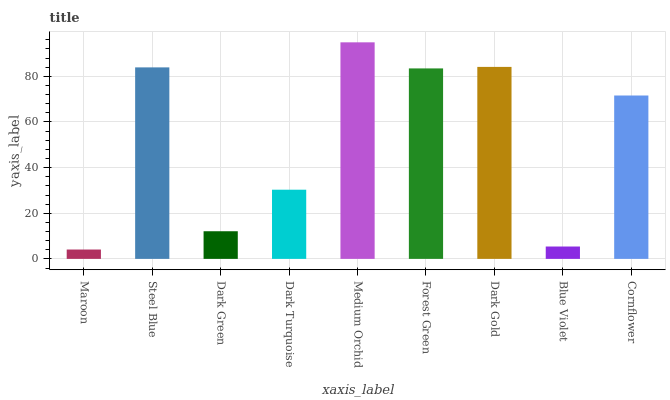Is Steel Blue the minimum?
Answer yes or no. No. Is Steel Blue the maximum?
Answer yes or no. No. Is Steel Blue greater than Maroon?
Answer yes or no. Yes. Is Maroon less than Steel Blue?
Answer yes or no. Yes. Is Maroon greater than Steel Blue?
Answer yes or no. No. Is Steel Blue less than Maroon?
Answer yes or no. No. Is Cornflower the high median?
Answer yes or no. Yes. Is Cornflower the low median?
Answer yes or no. Yes. Is Dark Green the high median?
Answer yes or no. No. Is Dark Gold the low median?
Answer yes or no. No. 